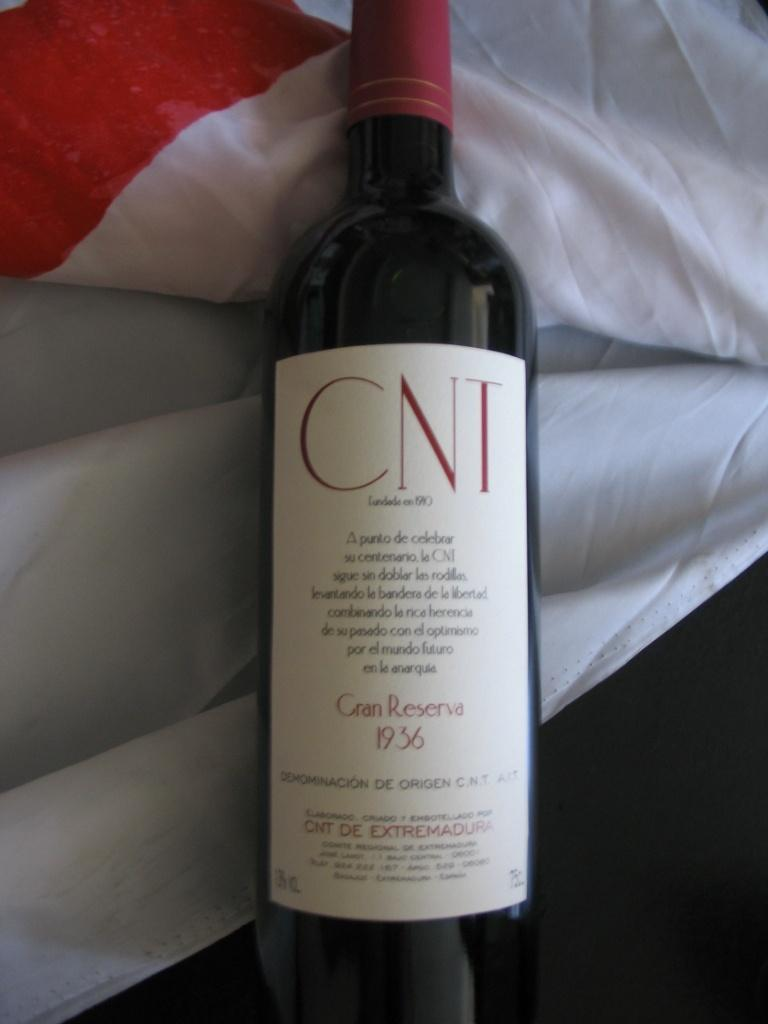<image>
Share a concise interpretation of the image provided. A bottle of Cran Reserva from 1936 is lying on a bed. 